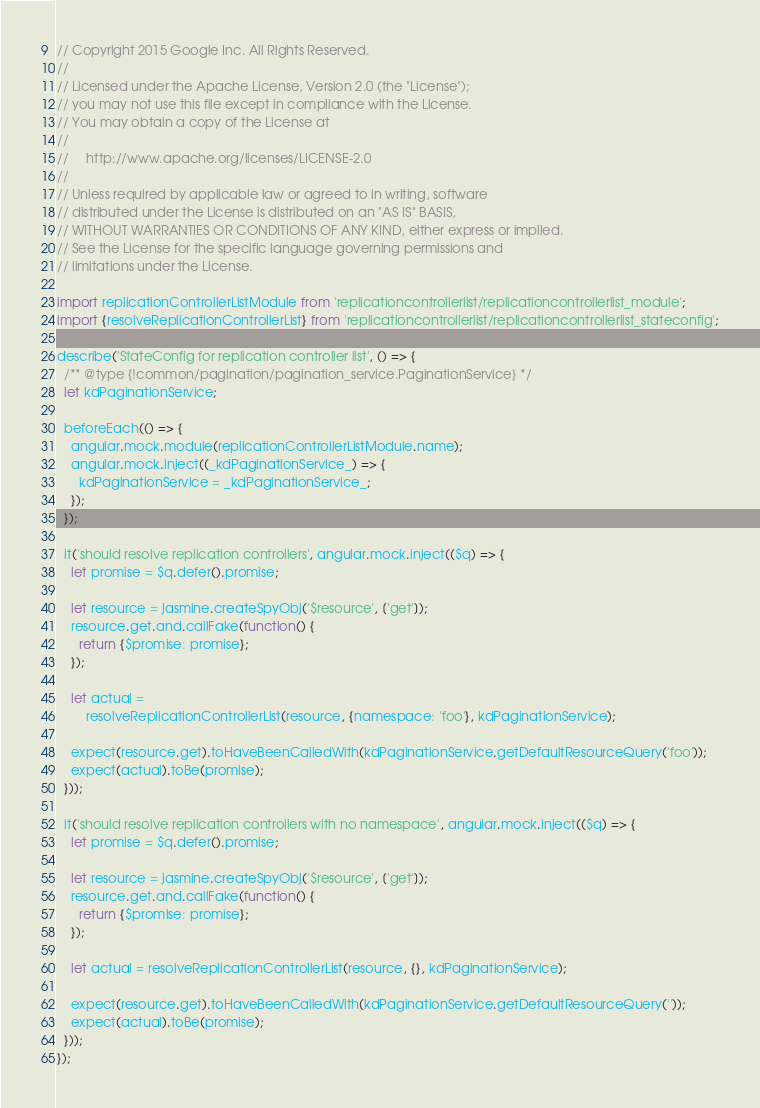<code> <loc_0><loc_0><loc_500><loc_500><_JavaScript_>// Copyright 2015 Google Inc. All Rights Reserved.
//
// Licensed under the Apache License, Version 2.0 (the "License");
// you may not use this file except in compliance with the License.
// You may obtain a copy of the License at
//
//     http://www.apache.org/licenses/LICENSE-2.0
//
// Unless required by applicable law or agreed to in writing, software
// distributed under the License is distributed on an "AS IS" BASIS,
// WITHOUT WARRANTIES OR CONDITIONS OF ANY KIND, either express or implied.
// See the License for the specific language governing permissions and
// limitations under the License.

import replicationControllerListModule from 'replicationcontrollerlist/replicationcontrollerlist_module';
import {resolveReplicationControllerList} from 'replicationcontrollerlist/replicationcontrollerlist_stateconfig';

describe('StateConfig for replication controller list', () => {
  /** @type {!common/pagination/pagination_service.PaginationService} */
  let kdPaginationService;

  beforeEach(() => {
    angular.mock.module(replicationControllerListModule.name);
    angular.mock.inject((_kdPaginationService_) => {
      kdPaginationService = _kdPaginationService_;
    });
  });

  it('should resolve replication controllers', angular.mock.inject(($q) => {
    let promise = $q.defer().promise;

    let resource = jasmine.createSpyObj('$resource', ['get']);
    resource.get.and.callFake(function() {
      return {$promise: promise};
    });

    let actual =
        resolveReplicationControllerList(resource, {namespace: 'foo'}, kdPaginationService);

    expect(resource.get).toHaveBeenCalledWith(kdPaginationService.getDefaultResourceQuery('foo'));
    expect(actual).toBe(promise);
  }));

  it('should resolve replication controllers with no namespace', angular.mock.inject(($q) => {
    let promise = $q.defer().promise;

    let resource = jasmine.createSpyObj('$resource', ['get']);
    resource.get.and.callFake(function() {
      return {$promise: promise};
    });

    let actual = resolveReplicationControllerList(resource, {}, kdPaginationService);

    expect(resource.get).toHaveBeenCalledWith(kdPaginationService.getDefaultResourceQuery(''));
    expect(actual).toBe(promise);
  }));
});
</code> 